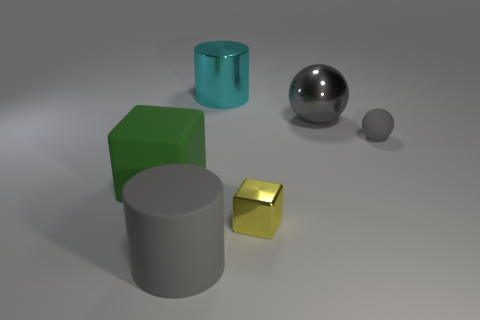There is a cylinder that is in front of the cyan cylinder; is it the same size as the metallic object on the right side of the tiny yellow object?
Make the answer very short. Yes. What number of large red rubber objects are there?
Provide a succinct answer. 0. How many large green things are made of the same material as the large cyan cylinder?
Offer a very short reply. 0. Are there an equal number of big gray metallic objects that are to the left of the big green rubber cube and gray rubber cubes?
Provide a succinct answer. Yes. What material is the tiny sphere that is the same color as the matte cylinder?
Make the answer very short. Rubber. There is a green rubber thing; does it have the same size as the rubber object behind the large matte cube?
Provide a succinct answer. No. How many other objects are the same size as the shiny block?
Ensure brevity in your answer.  1. How many other things are the same color as the big matte cylinder?
Your answer should be compact. 2. Is there anything else that has the same size as the yellow metal cube?
Give a very brief answer. Yes. How many other objects are there of the same shape as the tiny gray rubber object?
Keep it short and to the point. 1. 